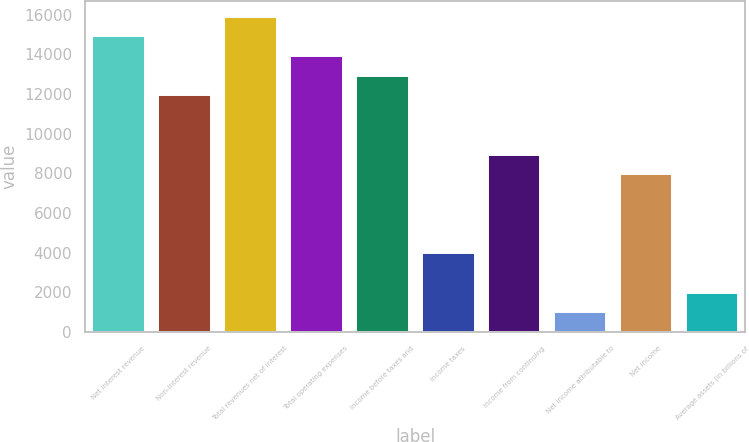Convert chart to OTSL. <chart><loc_0><loc_0><loc_500><loc_500><bar_chart><fcel>Net interest revenue<fcel>Non-interest revenue<fcel>Total revenues net of interest<fcel>Total operating expenses<fcel>Income before taxes and<fcel>Income taxes<fcel>Income from continuing<fcel>Net income attributable to<fcel>Net income<fcel>Average assets (in billions of<nl><fcel>14913.5<fcel>11933<fcel>15907<fcel>13920<fcel>12926.5<fcel>3985<fcel>8952.5<fcel>1004.5<fcel>7959<fcel>1998<nl></chart> 